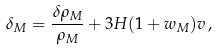<formula> <loc_0><loc_0><loc_500><loc_500>\delta _ { M } = \frac { \delta \rho _ { M } } { \rho _ { M } } + 3 H ( 1 + w _ { M } ) v \, ,</formula> 